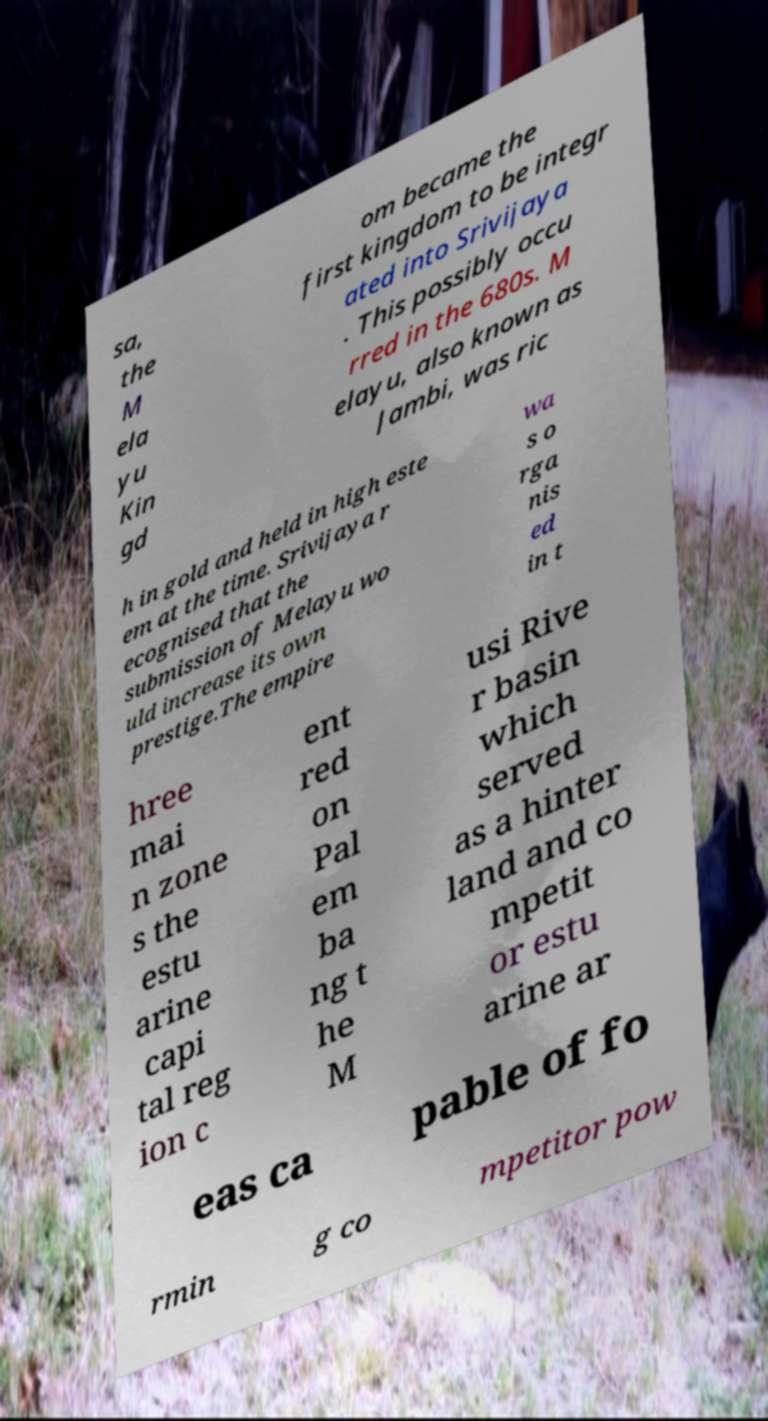What messages or text are displayed in this image? I need them in a readable, typed format. sa, the M ela yu Kin gd om became the first kingdom to be integr ated into Srivijaya . This possibly occu rred in the 680s. M elayu, also known as Jambi, was ric h in gold and held in high este em at the time. Srivijaya r ecognised that the submission of Melayu wo uld increase its own prestige.The empire wa s o rga nis ed in t hree mai n zone s the estu arine capi tal reg ion c ent red on Pal em ba ng t he M usi Rive r basin which served as a hinter land and co mpetit or estu arine ar eas ca pable of fo rmin g co mpetitor pow 